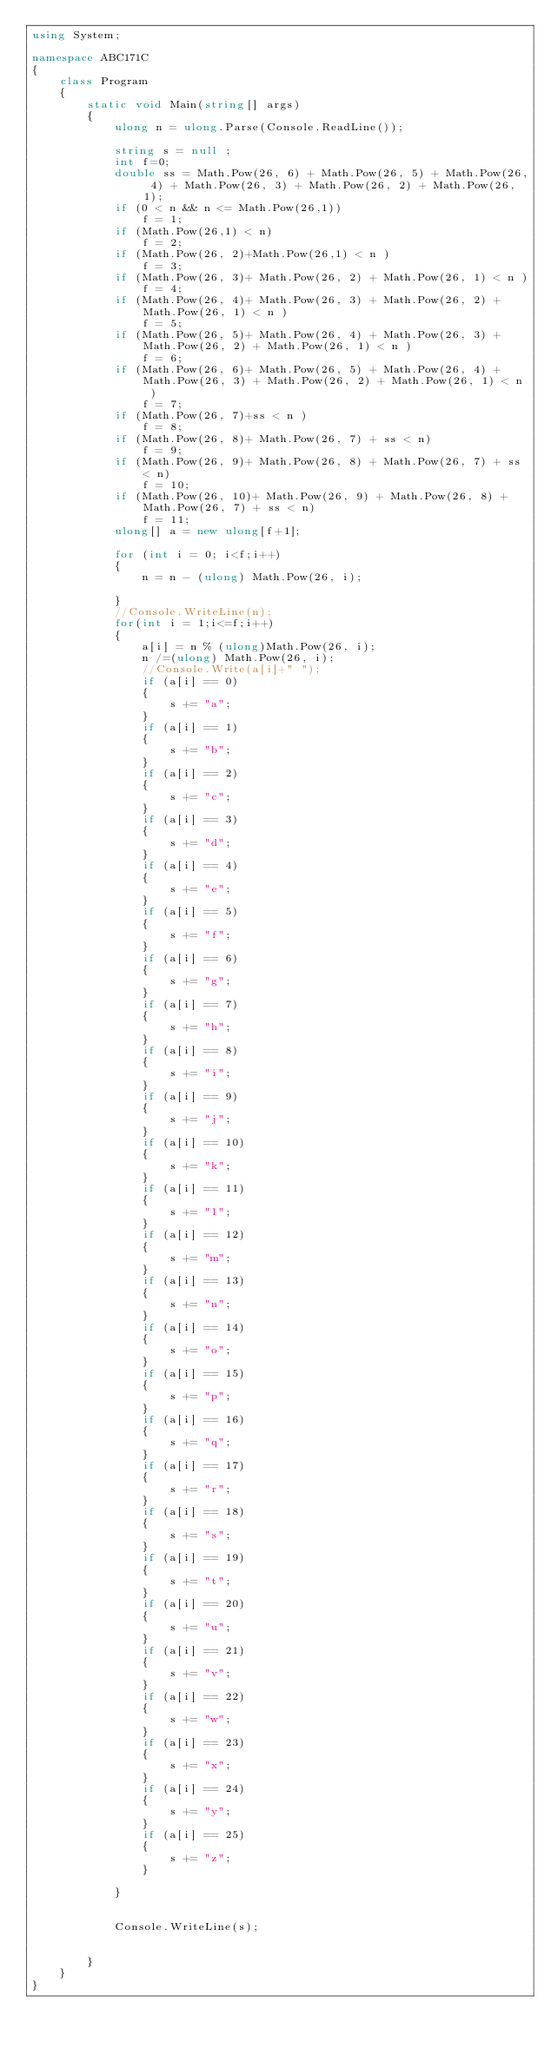<code> <loc_0><loc_0><loc_500><loc_500><_C#_>using System;

namespace ABC171C
{
    class Program
    {
        static void Main(string[] args)
        {
            ulong n = ulong.Parse(Console.ReadLine());
            
            string s = null ;
            int f=0;
            double ss = Math.Pow(26, 6) + Math.Pow(26, 5) + Math.Pow(26, 4) + Math.Pow(26, 3) + Math.Pow(26, 2) + Math.Pow(26, 1);
            if (0 < n && n <= Math.Pow(26,1))
                f = 1;
            if (Math.Pow(26,1) < n)
                f = 2;
            if (Math.Pow(26, 2)+Math.Pow(26,1) < n )
                f = 3;
            if (Math.Pow(26, 3)+ Math.Pow(26, 2) + Math.Pow(26, 1) < n )
                f = 4;
            if (Math.Pow(26, 4)+ Math.Pow(26, 3) + Math.Pow(26, 2) + Math.Pow(26, 1) < n )
                f = 5;
            if (Math.Pow(26, 5)+ Math.Pow(26, 4) + Math.Pow(26, 3) + Math.Pow(26, 2) + Math.Pow(26, 1) < n )
                f = 6;
            if (Math.Pow(26, 6)+ Math.Pow(26, 5) + Math.Pow(26, 4) + Math.Pow(26, 3) + Math.Pow(26, 2) + Math.Pow(26, 1) < n )
                f = 7;
            if (Math.Pow(26, 7)+ss < n )
                f = 8;
            if (Math.Pow(26, 8)+ Math.Pow(26, 7) + ss < n)
                f = 9;
            if (Math.Pow(26, 9)+ Math.Pow(26, 8) + Math.Pow(26, 7) + ss < n)
                f = 10;
            if (Math.Pow(26, 10)+ Math.Pow(26, 9) + Math.Pow(26, 8) + Math.Pow(26, 7) + ss < n)
                f = 11;
            ulong[] a = new ulong[f+1];
             
            for (int i = 0; i<f;i++)
            {
                n = n - (ulong) Math.Pow(26, i);

            }
            //Console.WriteLine(n);
            for(int i = 1;i<=f;i++)
            {
                a[i] = n % (ulong)Math.Pow(26, i);
                n /=(ulong) Math.Pow(26, i);
                //Console.Write(a[i]+" ");
                if (a[i] == 0)
                {
                    s += "a";
                }
                if (a[i] == 1)
                {
                    s += "b";
                }
                if (a[i] == 2)
                {
                    s += "c";
                }
                if (a[i] == 3)
                {
                    s += "d";
                }
                if (a[i] == 4)
                {
                    s += "e";
                }
                if (a[i] == 5)
                {
                    s += "f";
                }
                if (a[i] == 6)
                {
                    s += "g";
                }
                if (a[i] == 7)
                {
                    s += "h";
                }
                if (a[i] == 8)
                {
                    s += "i";
                }
                if (a[i] == 9)
                {
                    s += "j";
                }
                if (a[i] == 10)
                {
                    s += "k";
                }
                if (a[i] == 11)
                {
                    s += "l";
                }
                if (a[i] == 12)
                {
                    s += "m";
                }
                if (a[i] == 13)
                {
                    s += "n";
                }
                if (a[i] == 14)
                {
                    s += "o";
                }
                if (a[i] == 15)
                {
                    s += "p";
                }
                if (a[i] == 16)
                {
                    s += "q";
                }
                if (a[i] == 17)
                {
                    s += "r";
                }
                if (a[i] == 18)
                {
                    s += "s";
                }
                if (a[i] == 19)
                {
                    s += "t";
                }
                if (a[i] == 20)
                {
                    s += "u";
                }
                if (a[i] == 21)
                {
                    s += "v";
                }
                if (a[i] == 22)
                {
                    s += "w";
                }
                if (a[i] == 23)
                {
                    s += "x";
                }
                if (a[i] == 24)
                {
                    s += "y";
                }
                if (a[i] == 25)
                {
                    s += "z";
                }

            }


            Console.WriteLine(s);
            
      
        }
    }
}
</code> 